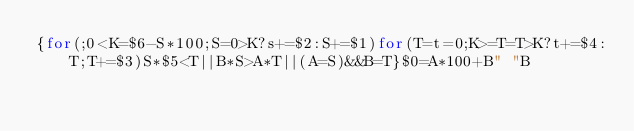Convert code to text. <code><loc_0><loc_0><loc_500><loc_500><_Awk_>{for(;0<K=$6-S*100;S=0>K?s+=$2:S+=$1)for(T=t=0;K>=T=T>K?t+=$4:T;T+=$3)S*$5<T||B*S>A*T||(A=S)&&B=T}$0=A*100+B" "B</code> 